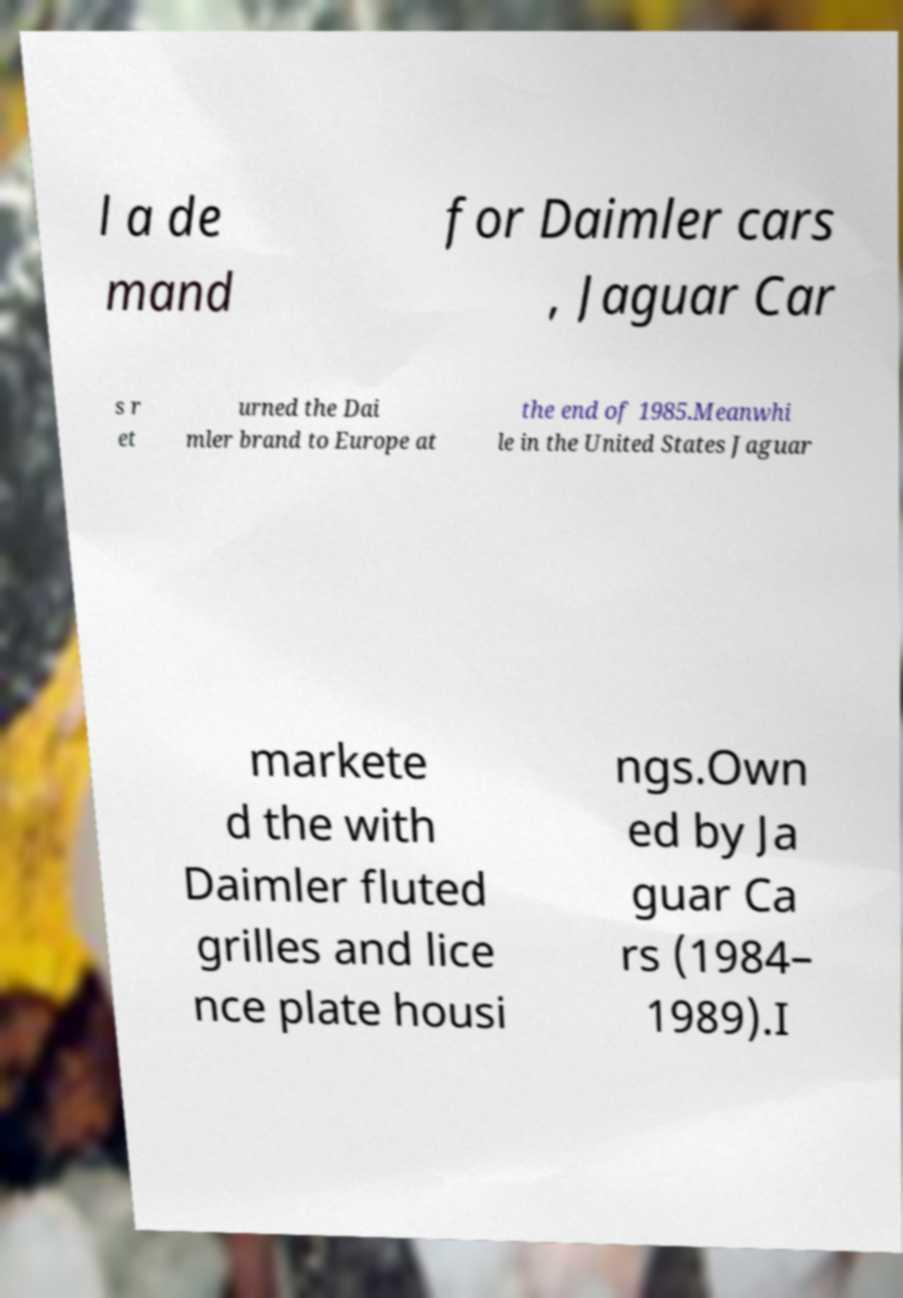I need the written content from this picture converted into text. Can you do that? l a de mand for Daimler cars , Jaguar Car s r et urned the Dai mler brand to Europe at the end of 1985.Meanwhi le in the United States Jaguar markete d the with Daimler fluted grilles and lice nce plate housi ngs.Own ed by Ja guar Ca rs (1984– 1989).I 